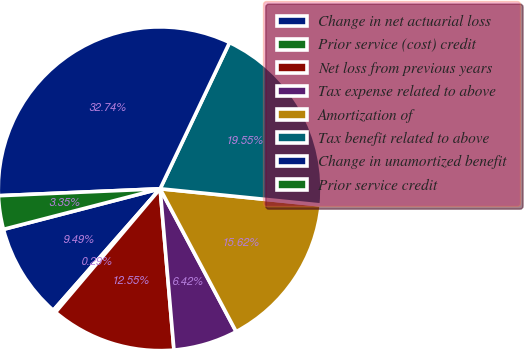Convert chart. <chart><loc_0><loc_0><loc_500><loc_500><pie_chart><fcel>Change in net actuarial loss<fcel>Prior service (cost) credit<fcel>Net loss from previous years<fcel>Tax expense related to above<fcel>Amortization of<fcel>Tax benefit related to above<fcel>Change in unamortized benefit<fcel>Prior service credit<nl><fcel>9.49%<fcel>0.29%<fcel>12.55%<fcel>6.42%<fcel>15.62%<fcel>19.55%<fcel>32.74%<fcel>3.35%<nl></chart> 